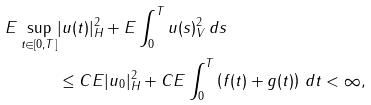Convert formula to latex. <formula><loc_0><loc_0><loc_500><loc_500>E \sup _ { t \in [ 0 , T ] } & | u ( t ) | ^ { 2 } _ { H } + E \int _ { 0 } ^ { T } \| u ( s ) \| ^ { 2 } _ { V } \, d s \\ & \leq C E | u _ { 0 } | _ { H } ^ { 2 } + C E \int _ { 0 } ^ { T } \left ( f ( t ) + g ( t ) \right ) \, d t < \infty ,</formula> 